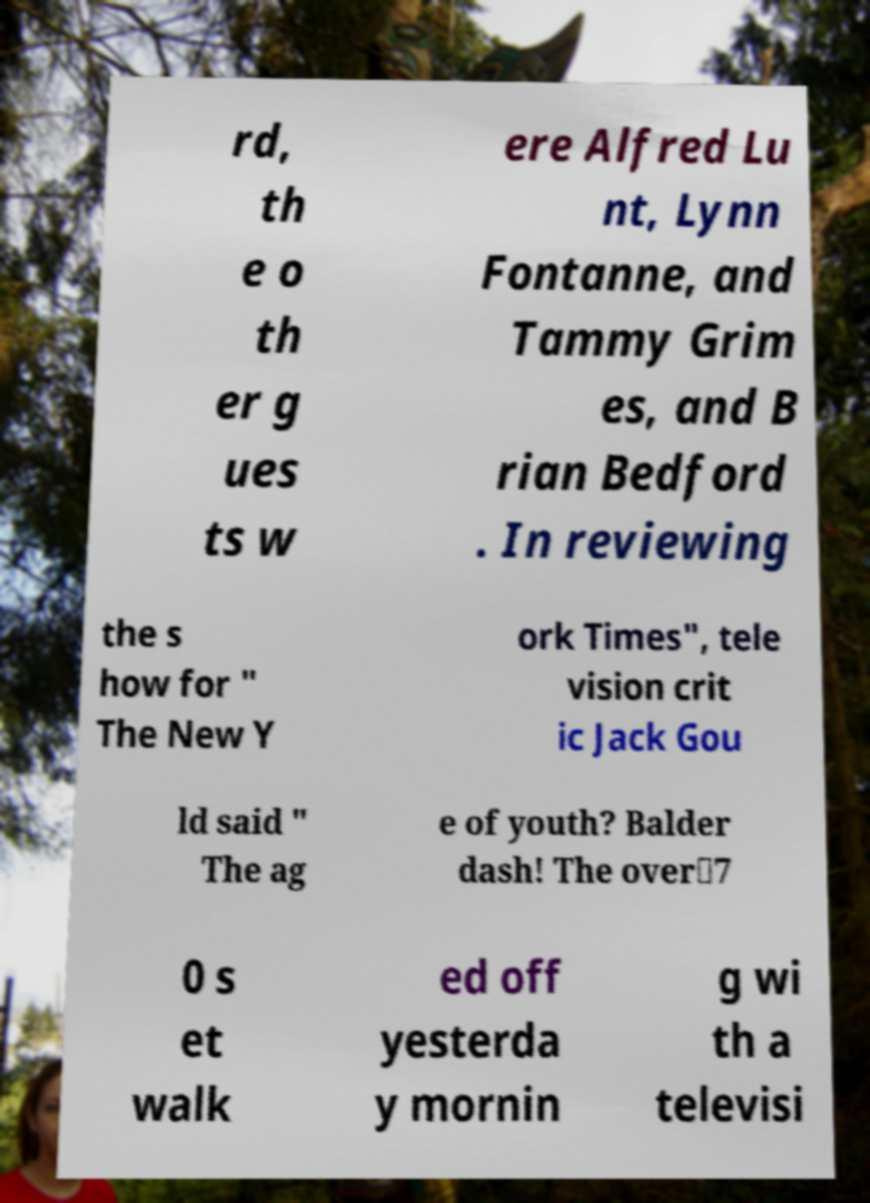I need the written content from this picture converted into text. Can you do that? rd, th e o th er g ues ts w ere Alfred Lu nt, Lynn Fontanne, and Tammy Grim es, and B rian Bedford . In reviewing the s how for " The New Y ork Times", tele vision crit ic Jack Gou ld said " The ag e of youth? Balder dash! The over‐7 0 s et walk ed off yesterda y mornin g wi th a televisi 